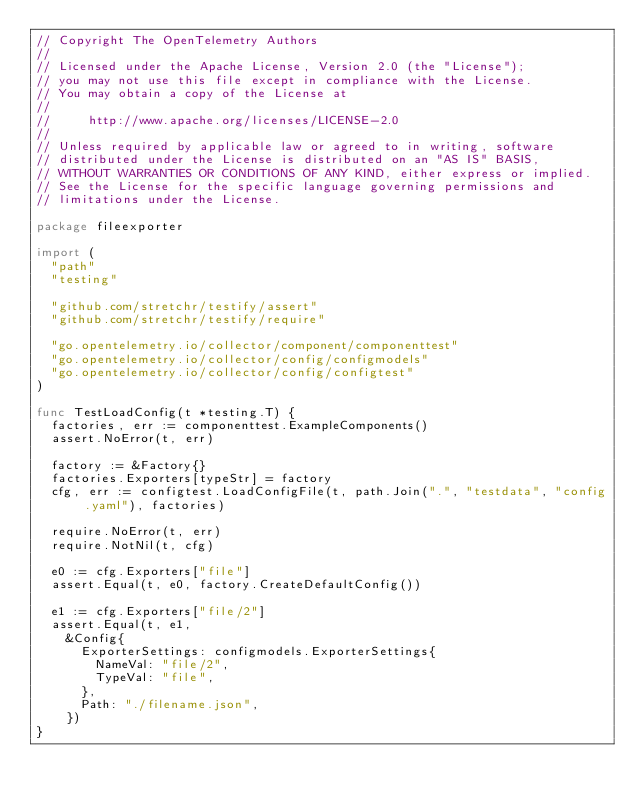<code> <loc_0><loc_0><loc_500><loc_500><_Go_>// Copyright The OpenTelemetry Authors
//
// Licensed under the Apache License, Version 2.0 (the "License");
// you may not use this file except in compliance with the License.
// You may obtain a copy of the License at
//
//     http://www.apache.org/licenses/LICENSE-2.0
//
// Unless required by applicable law or agreed to in writing, software
// distributed under the License is distributed on an "AS IS" BASIS,
// WITHOUT WARRANTIES OR CONDITIONS OF ANY KIND, either express or implied.
// See the License for the specific language governing permissions and
// limitations under the License.

package fileexporter

import (
	"path"
	"testing"

	"github.com/stretchr/testify/assert"
	"github.com/stretchr/testify/require"

	"go.opentelemetry.io/collector/component/componenttest"
	"go.opentelemetry.io/collector/config/configmodels"
	"go.opentelemetry.io/collector/config/configtest"
)

func TestLoadConfig(t *testing.T) {
	factories, err := componenttest.ExampleComponents()
	assert.NoError(t, err)

	factory := &Factory{}
	factories.Exporters[typeStr] = factory
	cfg, err := configtest.LoadConfigFile(t, path.Join(".", "testdata", "config.yaml"), factories)

	require.NoError(t, err)
	require.NotNil(t, cfg)

	e0 := cfg.Exporters["file"]
	assert.Equal(t, e0, factory.CreateDefaultConfig())

	e1 := cfg.Exporters["file/2"]
	assert.Equal(t, e1,
		&Config{
			ExporterSettings: configmodels.ExporterSettings{
				NameVal: "file/2",
				TypeVal: "file",
			},
			Path: "./filename.json",
		})
}
</code> 